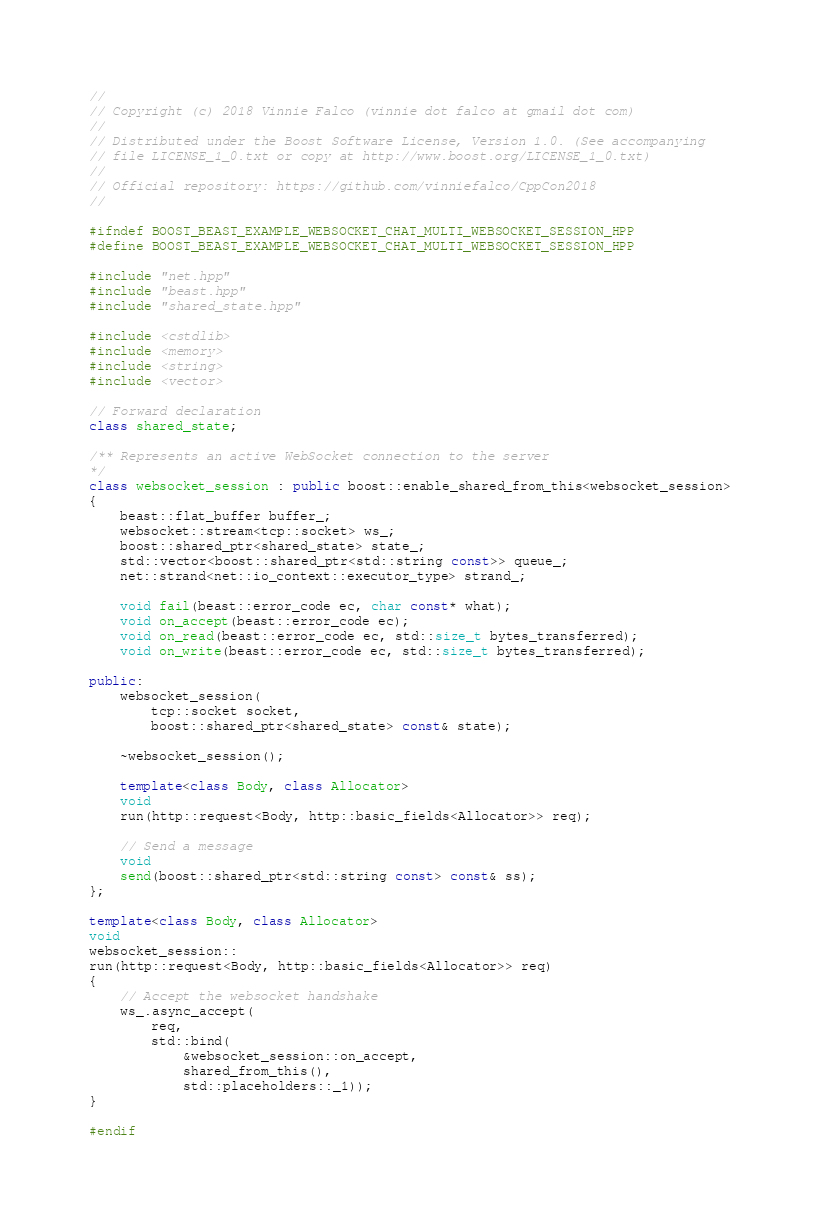<code> <loc_0><loc_0><loc_500><loc_500><_C++_>//
// Copyright (c) 2018 Vinnie Falco (vinnie dot falco at gmail dot com)
//
// Distributed under the Boost Software License, Version 1.0. (See accompanying
// file LICENSE_1_0.txt or copy at http://www.boost.org/LICENSE_1_0.txt)
//
// Official repository: https://github.com/vinniefalco/CppCon2018
//

#ifndef BOOST_BEAST_EXAMPLE_WEBSOCKET_CHAT_MULTI_WEBSOCKET_SESSION_HPP
#define BOOST_BEAST_EXAMPLE_WEBSOCKET_CHAT_MULTI_WEBSOCKET_SESSION_HPP

#include "net.hpp"
#include "beast.hpp"
#include "shared_state.hpp"

#include <cstdlib>
#include <memory>
#include <string>
#include <vector>

// Forward declaration
class shared_state;

/** Represents an active WebSocket connection to the server
*/
class websocket_session : public boost::enable_shared_from_this<websocket_session>
{
    beast::flat_buffer buffer_;
    websocket::stream<tcp::socket> ws_;
    boost::shared_ptr<shared_state> state_;
    std::vector<boost::shared_ptr<std::string const>> queue_;
    net::strand<net::io_context::executor_type> strand_;

    void fail(beast::error_code ec, char const* what);
    void on_accept(beast::error_code ec);
    void on_read(beast::error_code ec, std::size_t bytes_transferred);
    void on_write(beast::error_code ec, std::size_t bytes_transferred);

public:
    websocket_session(
        tcp::socket socket,
        boost::shared_ptr<shared_state> const& state);

    ~websocket_session();

    template<class Body, class Allocator>
    void
    run(http::request<Body, http::basic_fields<Allocator>> req);

    // Send a message
    void
    send(boost::shared_ptr<std::string const> const& ss);
};

template<class Body, class Allocator>
void
websocket_session::
run(http::request<Body, http::basic_fields<Allocator>> req)
{
    // Accept the websocket handshake
    ws_.async_accept(
        req,
        std::bind(
            &websocket_session::on_accept,
            shared_from_this(),
            std::placeholders::_1));
}

#endif
</code> 